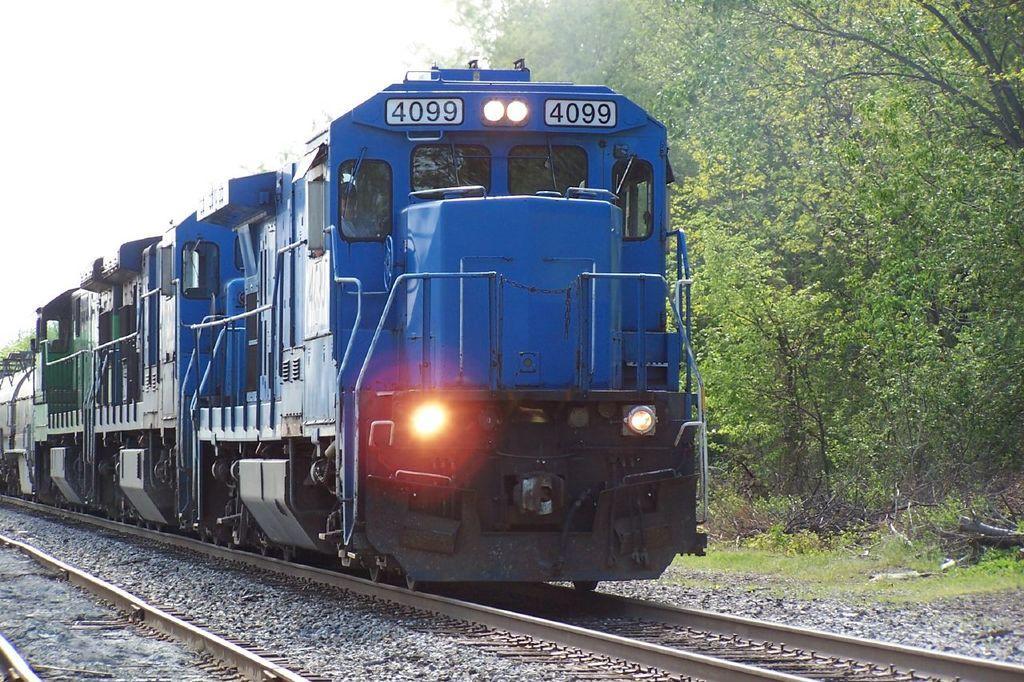Describe this image in one or two sentences. In this image there are tracks, on one track there is a train moving, on the right side there are trees. 